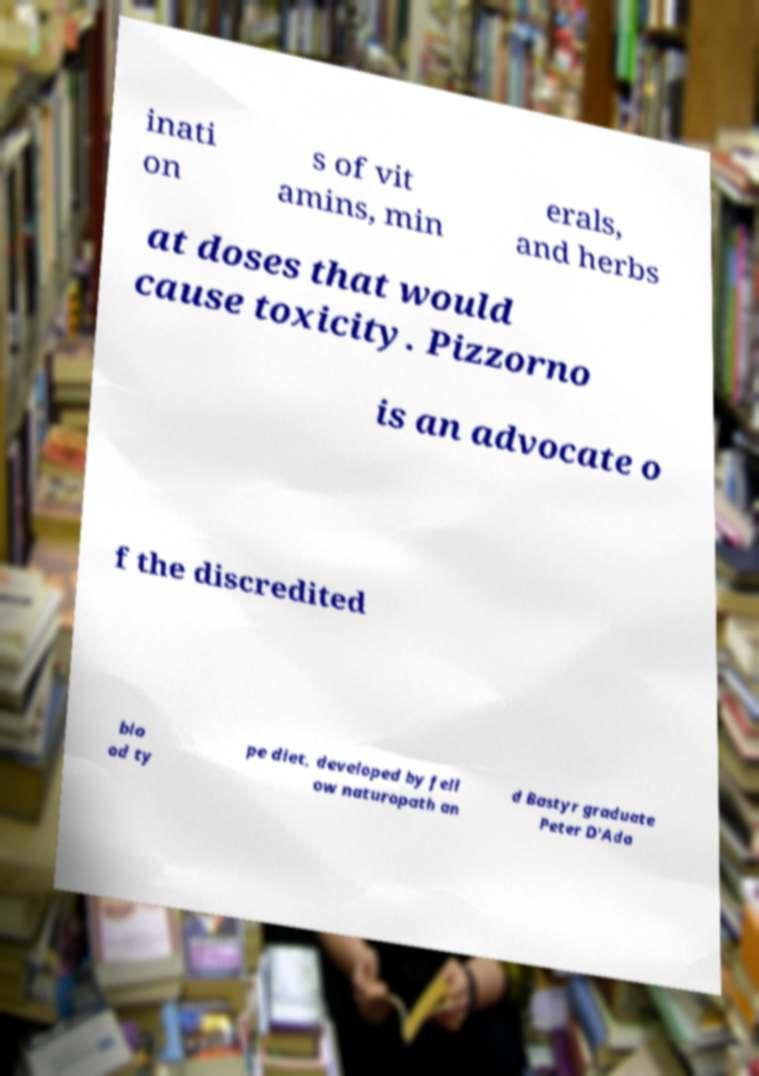Can you accurately transcribe the text from the provided image for me? inati on s of vit amins, min erals, and herbs at doses that would cause toxicity. Pizzorno is an advocate o f the discredited blo od ty pe diet, developed by fell ow naturopath an d Bastyr graduate Peter D'Ada 